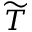<formula> <loc_0><loc_0><loc_500><loc_500>\widetilde { T }</formula> 